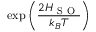<formula> <loc_0><loc_0><loc_500><loc_500>\exp \left ( \frac { 2 H _ { S O } } { k _ { B } T } \right )</formula> 